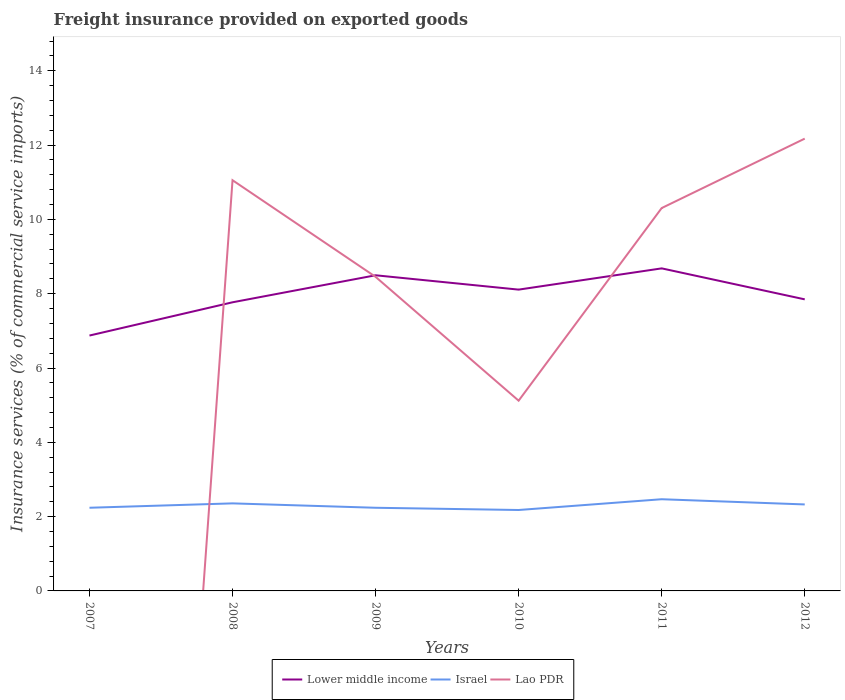Does the line corresponding to Lower middle income intersect with the line corresponding to Lao PDR?
Offer a very short reply. Yes. Is the number of lines equal to the number of legend labels?
Make the answer very short. No. Across all years, what is the maximum freight insurance provided on exported goods in Lower middle income?
Give a very brief answer. 6.87. What is the total freight insurance provided on exported goods in Lower middle income in the graph?
Ensure brevity in your answer.  -0.91. What is the difference between the highest and the second highest freight insurance provided on exported goods in Israel?
Offer a terse response. 0.29. What is the difference between the highest and the lowest freight insurance provided on exported goods in Lao PDR?
Offer a terse response. 4. Is the freight insurance provided on exported goods in Israel strictly greater than the freight insurance provided on exported goods in Lao PDR over the years?
Your response must be concise. No. How many lines are there?
Your response must be concise. 3. Does the graph contain grids?
Offer a terse response. No. What is the title of the graph?
Offer a very short reply. Freight insurance provided on exported goods. Does "Belarus" appear as one of the legend labels in the graph?
Ensure brevity in your answer.  No. What is the label or title of the X-axis?
Offer a terse response. Years. What is the label or title of the Y-axis?
Give a very brief answer. Insurance services (% of commercial service imports). What is the Insurance services (% of commercial service imports) of Lower middle income in 2007?
Ensure brevity in your answer.  6.87. What is the Insurance services (% of commercial service imports) in Israel in 2007?
Make the answer very short. 2.24. What is the Insurance services (% of commercial service imports) of Lao PDR in 2007?
Give a very brief answer. 0. What is the Insurance services (% of commercial service imports) of Lower middle income in 2008?
Give a very brief answer. 7.77. What is the Insurance services (% of commercial service imports) of Israel in 2008?
Make the answer very short. 2.36. What is the Insurance services (% of commercial service imports) of Lao PDR in 2008?
Offer a very short reply. 11.05. What is the Insurance services (% of commercial service imports) in Lower middle income in 2009?
Offer a terse response. 8.5. What is the Insurance services (% of commercial service imports) in Israel in 2009?
Make the answer very short. 2.24. What is the Insurance services (% of commercial service imports) of Lao PDR in 2009?
Your answer should be very brief. 8.45. What is the Insurance services (% of commercial service imports) of Lower middle income in 2010?
Give a very brief answer. 8.11. What is the Insurance services (% of commercial service imports) of Israel in 2010?
Your response must be concise. 2.18. What is the Insurance services (% of commercial service imports) of Lao PDR in 2010?
Provide a short and direct response. 5.12. What is the Insurance services (% of commercial service imports) of Lower middle income in 2011?
Your answer should be very brief. 8.68. What is the Insurance services (% of commercial service imports) in Israel in 2011?
Provide a succinct answer. 2.47. What is the Insurance services (% of commercial service imports) of Lao PDR in 2011?
Keep it short and to the point. 10.31. What is the Insurance services (% of commercial service imports) of Lower middle income in 2012?
Ensure brevity in your answer.  7.85. What is the Insurance services (% of commercial service imports) of Israel in 2012?
Your answer should be very brief. 2.33. What is the Insurance services (% of commercial service imports) in Lao PDR in 2012?
Offer a terse response. 12.17. Across all years, what is the maximum Insurance services (% of commercial service imports) of Lower middle income?
Make the answer very short. 8.68. Across all years, what is the maximum Insurance services (% of commercial service imports) of Israel?
Offer a very short reply. 2.47. Across all years, what is the maximum Insurance services (% of commercial service imports) of Lao PDR?
Provide a succinct answer. 12.17. Across all years, what is the minimum Insurance services (% of commercial service imports) of Lower middle income?
Your response must be concise. 6.87. Across all years, what is the minimum Insurance services (% of commercial service imports) of Israel?
Make the answer very short. 2.18. What is the total Insurance services (% of commercial service imports) in Lower middle income in the graph?
Make the answer very short. 47.78. What is the total Insurance services (% of commercial service imports) of Israel in the graph?
Your answer should be very brief. 13.81. What is the total Insurance services (% of commercial service imports) in Lao PDR in the graph?
Your answer should be very brief. 47.11. What is the difference between the Insurance services (% of commercial service imports) in Lower middle income in 2007 and that in 2008?
Your answer should be compact. -0.9. What is the difference between the Insurance services (% of commercial service imports) in Israel in 2007 and that in 2008?
Offer a very short reply. -0.12. What is the difference between the Insurance services (% of commercial service imports) of Lower middle income in 2007 and that in 2009?
Give a very brief answer. -1.62. What is the difference between the Insurance services (% of commercial service imports) of Lower middle income in 2007 and that in 2010?
Your answer should be very brief. -1.24. What is the difference between the Insurance services (% of commercial service imports) in Israel in 2007 and that in 2010?
Give a very brief answer. 0.06. What is the difference between the Insurance services (% of commercial service imports) in Lower middle income in 2007 and that in 2011?
Provide a succinct answer. -1.81. What is the difference between the Insurance services (% of commercial service imports) in Israel in 2007 and that in 2011?
Offer a very short reply. -0.23. What is the difference between the Insurance services (% of commercial service imports) in Lower middle income in 2007 and that in 2012?
Your answer should be very brief. -0.97. What is the difference between the Insurance services (% of commercial service imports) in Israel in 2007 and that in 2012?
Ensure brevity in your answer.  -0.09. What is the difference between the Insurance services (% of commercial service imports) in Lower middle income in 2008 and that in 2009?
Your answer should be very brief. -0.73. What is the difference between the Insurance services (% of commercial service imports) of Israel in 2008 and that in 2009?
Make the answer very short. 0.12. What is the difference between the Insurance services (% of commercial service imports) in Lao PDR in 2008 and that in 2009?
Make the answer very short. 2.6. What is the difference between the Insurance services (% of commercial service imports) of Lower middle income in 2008 and that in 2010?
Give a very brief answer. -0.34. What is the difference between the Insurance services (% of commercial service imports) in Israel in 2008 and that in 2010?
Your response must be concise. 0.18. What is the difference between the Insurance services (% of commercial service imports) of Lao PDR in 2008 and that in 2010?
Make the answer very short. 5.93. What is the difference between the Insurance services (% of commercial service imports) of Lower middle income in 2008 and that in 2011?
Your answer should be compact. -0.91. What is the difference between the Insurance services (% of commercial service imports) in Israel in 2008 and that in 2011?
Your response must be concise. -0.11. What is the difference between the Insurance services (% of commercial service imports) in Lao PDR in 2008 and that in 2011?
Your answer should be compact. 0.75. What is the difference between the Insurance services (% of commercial service imports) of Lower middle income in 2008 and that in 2012?
Make the answer very short. -0.08. What is the difference between the Insurance services (% of commercial service imports) of Israel in 2008 and that in 2012?
Your response must be concise. 0.03. What is the difference between the Insurance services (% of commercial service imports) of Lao PDR in 2008 and that in 2012?
Keep it short and to the point. -1.12. What is the difference between the Insurance services (% of commercial service imports) in Lower middle income in 2009 and that in 2010?
Your answer should be compact. 0.39. What is the difference between the Insurance services (% of commercial service imports) of Israel in 2009 and that in 2010?
Keep it short and to the point. 0.06. What is the difference between the Insurance services (% of commercial service imports) in Lao PDR in 2009 and that in 2010?
Give a very brief answer. 3.33. What is the difference between the Insurance services (% of commercial service imports) in Lower middle income in 2009 and that in 2011?
Offer a very short reply. -0.19. What is the difference between the Insurance services (% of commercial service imports) in Israel in 2009 and that in 2011?
Provide a succinct answer. -0.23. What is the difference between the Insurance services (% of commercial service imports) of Lao PDR in 2009 and that in 2011?
Offer a very short reply. -1.85. What is the difference between the Insurance services (% of commercial service imports) of Lower middle income in 2009 and that in 2012?
Your answer should be compact. 0.65. What is the difference between the Insurance services (% of commercial service imports) of Israel in 2009 and that in 2012?
Provide a succinct answer. -0.09. What is the difference between the Insurance services (% of commercial service imports) in Lao PDR in 2009 and that in 2012?
Provide a short and direct response. -3.72. What is the difference between the Insurance services (% of commercial service imports) of Lower middle income in 2010 and that in 2011?
Offer a terse response. -0.57. What is the difference between the Insurance services (% of commercial service imports) in Israel in 2010 and that in 2011?
Offer a very short reply. -0.29. What is the difference between the Insurance services (% of commercial service imports) of Lao PDR in 2010 and that in 2011?
Keep it short and to the point. -5.18. What is the difference between the Insurance services (% of commercial service imports) of Lower middle income in 2010 and that in 2012?
Your answer should be compact. 0.26. What is the difference between the Insurance services (% of commercial service imports) of Israel in 2010 and that in 2012?
Provide a succinct answer. -0.15. What is the difference between the Insurance services (% of commercial service imports) in Lao PDR in 2010 and that in 2012?
Your answer should be compact. -7.05. What is the difference between the Insurance services (% of commercial service imports) of Lower middle income in 2011 and that in 2012?
Ensure brevity in your answer.  0.83. What is the difference between the Insurance services (% of commercial service imports) of Israel in 2011 and that in 2012?
Offer a very short reply. 0.14. What is the difference between the Insurance services (% of commercial service imports) in Lao PDR in 2011 and that in 2012?
Your response must be concise. -1.87. What is the difference between the Insurance services (% of commercial service imports) of Lower middle income in 2007 and the Insurance services (% of commercial service imports) of Israel in 2008?
Provide a succinct answer. 4.52. What is the difference between the Insurance services (% of commercial service imports) of Lower middle income in 2007 and the Insurance services (% of commercial service imports) of Lao PDR in 2008?
Provide a short and direct response. -4.18. What is the difference between the Insurance services (% of commercial service imports) in Israel in 2007 and the Insurance services (% of commercial service imports) in Lao PDR in 2008?
Give a very brief answer. -8.82. What is the difference between the Insurance services (% of commercial service imports) of Lower middle income in 2007 and the Insurance services (% of commercial service imports) of Israel in 2009?
Your response must be concise. 4.64. What is the difference between the Insurance services (% of commercial service imports) in Lower middle income in 2007 and the Insurance services (% of commercial service imports) in Lao PDR in 2009?
Your answer should be compact. -1.58. What is the difference between the Insurance services (% of commercial service imports) of Israel in 2007 and the Insurance services (% of commercial service imports) of Lao PDR in 2009?
Give a very brief answer. -6.22. What is the difference between the Insurance services (% of commercial service imports) of Lower middle income in 2007 and the Insurance services (% of commercial service imports) of Israel in 2010?
Your answer should be compact. 4.7. What is the difference between the Insurance services (% of commercial service imports) of Lower middle income in 2007 and the Insurance services (% of commercial service imports) of Lao PDR in 2010?
Ensure brevity in your answer.  1.75. What is the difference between the Insurance services (% of commercial service imports) of Israel in 2007 and the Insurance services (% of commercial service imports) of Lao PDR in 2010?
Offer a terse response. -2.88. What is the difference between the Insurance services (% of commercial service imports) of Lower middle income in 2007 and the Insurance services (% of commercial service imports) of Israel in 2011?
Make the answer very short. 4.41. What is the difference between the Insurance services (% of commercial service imports) of Lower middle income in 2007 and the Insurance services (% of commercial service imports) of Lao PDR in 2011?
Your answer should be compact. -3.43. What is the difference between the Insurance services (% of commercial service imports) of Israel in 2007 and the Insurance services (% of commercial service imports) of Lao PDR in 2011?
Provide a succinct answer. -8.07. What is the difference between the Insurance services (% of commercial service imports) in Lower middle income in 2007 and the Insurance services (% of commercial service imports) in Israel in 2012?
Make the answer very short. 4.55. What is the difference between the Insurance services (% of commercial service imports) in Lower middle income in 2007 and the Insurance services (% of commercial service imports) in Lao PDR in 2012?
Your response must be concise. -5.3. What is the difference between the Insurance services (% of commercial service imports) in Israel in 2007 and the Insurance services (% of commercial service imports) in Lao PDR in 2012?
Your answer should be very brief. -9.94. What is the difference between the Insurance services (% of commercial service imports) in Lower middle income in 2008 and the Insurance services (% of commercial service imports) in Israel in 2009?
Provide a short and direct response. 5.53. What is the difference between the Insurance services (% of commercial service imports) in Lower middle income in 2008 and the Insurance services (% of commercial service imports) in Lao PDR in 2009?
Your answer should be compact. -0.68. What is the difference between the Insurance services (% of commercial service imports) of Israel in 2008 and the Insurance services (% of commercial service imports) of Lao PDR in 2009?
Make the answer very short. -6.1. What is the difference between the Insurance services (% of commercial service imports) of Lower middle income in 2008 and the Insurance services (% of commercial service imports) of Israel in 2010?
Keep it short and to the point. 5.59. What is the difference between the Insurance services (% of commercial service imports) in Lower middle income in 2008 and the Insurance services (% of commercial service imports) in Lao PDR in 2010?
Offer a very short reply. 2.65. What is the difference between the Insurance services (% of commercial service imports) of Israel in 2008 and the Insurance services (% of commercial service imports) of Lao PDR in 2010?
Offer a terse response. -2.76. What is the difference between the Insurance services (% of commercial service imports) in Lower middle income in 2008 and the Insurance services (% of commercial service imports) in Israel in 2011?
Give a very brief answer. 5.3. What is the difference between the Insurance services (% of commercial service imports) of Lower middle income in 2008 and the Insurance services (% of commercial service imports) of Lao PDR in 2011?
Offer a very short reply. -2.54. What is the difference between the Insurance services (% of commercial service imports) in Israel in 2008 and the Insurance services (% of commercial service imports) in Lao PDR in 2011?
Make the answer very short. -7.95. What is the difference between the Insurance services (% of commercial service imports) of Lower middle income in 2008 and the Insurance services (% of commercial service imports) of Israel in 2012?
Your response must be concise. 5.44. What is the difference between the Insurance services (% of commercial service imports) in Lower middle income in 2008 and the Insurance services (% of commercial service imports) in Lao PDR in 2012?
Provide a short and direct response. -4.41. What is the difference between the Insurance services (% of commercial service imports) in Israel in 2008 and the Insurance services (% of commercial service imports) in Lao PDR in 2012?
Your response must be concise. -9.82. What is the difference between the Insurance services (% of commercial service imports) of Lower middle income in 2009 and the Insurance services (% of commercial service imports) of Israel in 2010?
Ensure brevity in your answer.  6.32. What is the difference between the Insurance services (% of commercial service imports) of Lower middle income in 2009 and the Insurance services (% of commercial service imports) of Lao PDR in 2010?
Give a very brief answer. 3.38. What is the difference between the Insurance services (% of commercial service imports) of Israel in 2009 and the Insurance services (% of commercial service imports) of Lao PDR in 2010?
Offer a very short reply. -2.88. What is the difference between the Insurance services (% of commercial service imports) of Lower middle income in 2009 and the Insurance services (% of commercial service imports) of Israel in 2011?
Offer a terse response. 6.03. What is the difference between the Insurance services (% of commercial service imports) in Lower middle income in 2009 and the Insurance services (% of commercial service imports) in Lao PDR in 2011?
Your answer should be compact. -1.81. What is the difference between the Insurance services (% of commercial service imports) in Israel in 2009 and the Insurance services (% of commercial service imports) in Lao PDR in 2011?
Make the answer very short. -8.07. What is the difference between the Insurance services (% of commercial service imports) in Lower middle income in 2009 and the Insurance services (% of commercial service imports) in Israel in 2012?
Your answer should be compact. 6.17. What is the difference between the Insurance services (% of commercial service imports) of Lower middle income in 2009 and the Insurance services (% of commercial service imports) of Lao PDR in 2012?
Your answer should be very brief. -3.68. What is the difference between the Insurance services (% of commercial service imports) in Israel in 2009 and the Insurance services (% of commercial service imports) in Lao PDR in 2012?
Your answer should be compact. -9.94. What is the difference between the Insurance services (% of commercial service imports) in Lower middle income in 2010 and the Insurance services (% of commercial service imports) in Israel in 2011?
Provide a succinct answer. 5.64. What is the difference between the Insurance services (% of commercial service imports) of Lower middle income in 2010 and the Insurance services (% of commercial service imports) of Lao PDR in 2011?
Your response must be concise. -2.2. What is the difference between the Insurance services (% of commercial service imports) in Israel in 2010 and the Insurance services (% of commercial service imports) in Lao PDR in 2011?
Provide a succinct answer. -8.13. What is the difference between the Insurance services (% of commercial service imports) of Lower middle income in 2010 and the Insurance services (% of commercial service imports) of Israel in 2012?
Make the answer very short. 5.78. What is the difference between the Insurance services (% of commercial service imports) in Lower middle income in 2010 and the Insurance services (% of commercial service imports) in Lao PDR in 2012?
Your answer should be compact. -4.06. What is the difference between the Insurance services (% of commercial service imports) of Israel in 2010 and the Insurance services (% of commercial service imports) of Lao PDR in 2012?
Provide a short and direct response. -10. What is the difference between the Insurance services (% of commercial service imports) of Lower middle income in 2011 and the Insurance services (% of commercial service imports) of Israel in 2012?
Offer a very short reply. 6.35. What is the difference between the Insurance services (% of commercial service imports) in Lower middle income in 2011 and the Insurance services (% of commercial service imports) in Lao PDR in 2012?
Give a very brief answer. -3.49. What is the difference between the Insurance services (% of commercial service imports) in Israel in 2011 and the Insurance services (% of commercial service imports) in Lao PDR in 2012?
Give a very brief answer. -9.71. What is the average Insurance services (% of commercial service imports) of Lower middle income per year?
Your answer should be very brief. 7.96. What is the average Insurance services (% of commercial service imports) of Israel per year?
Offer a very short reply. 2.3. What is the average Insurance services (% of commercial service imports) in Lao PDR per year?
Make the answer very short. 7.85. In the year 2007, what is the difference between the Insurance services (% of commercial service imports) of Lower middle income and Insurance services (% of commercial service imports) of Israel?
Offer a very short reply. 4.64. In the year 2008, what is the difference between the Insurance services (% of commercial service imports) in Lower middle income and Insurance services (% of commercial service imports) in Israel?
Your answer should be very brief. 5.41. In the year 2008, what is the difference between the Insurance services (% of commercial service imports) of Lower middle income and Insurance services (% of commercial service imports) of Lao PDR?
Keep it short and to the point. -3.29. In the year 2008, what is the difference between the Insurance services (% of commercial service imports) in Israel and Insurance services (% of commercial service imports) in Lao PDR?
Ensure brevity in your answer.  -8.7. In the year 2009, what is the difference between the Insurance services (% of commercial service imports) in Lower middle income and Insurance services (% of commercial service imports) in Israel?
Ensure brevity in your answer.  6.26. In the year 2009, what is the difference between the Insurance services (% of commercial service imports) of Lower middle income and Insurance services (% of commercial service imports) of Lao PDR?
Your answer should be very brief. 0.04. In the year 2009, what is the difference between the Insurance services (% of commercial service imports) of Israel and Insurance services (% of commercial service imports) of Lao PDR?
Provide a short and direct response. -6.22. In the year 2010, what is the difference between the Insurance services (% of commercial service imports) in Lower middle income and Insurance services (% of commercial service imports) in Israel?
Offer a very short reply. 5.93. In the year 2010, what is the difference between the Insurance services (% of commercial service imports) of Lower middle income and Insurance services (% of commercial service imports) of Lao PDR?
Provide a succinct answer. 2.99. In the year 2010, what is the difference between the Insurance services (% of commercial service imports) of Israel and Insurance services (% of commercial service imports) of Lao PDR?
Your answer should be very brief. -2.94. In the year 2011, what is the difference between the Insurance services (% of commercial service imports) in Lower middle income and Insurance services (% of commercial service imports) in Israel?
Offer a very short reply. 6.21. In the year 2011, what is the difference between the Insurance services (% of commercial service imports) of Lower middle income and Insurance services (% of commercial service imports) of Lao PDR?
Your answer should be compact. -1.62. In the year 2011, what is the difference between the Insurance services (% of commercial service imports) in Israel and Insurance services (% of commercial service imports) in Lao PDR?
Give a very brief answer. -7.84. In the year 2012, what is the difference between the Insurance services (% of commercial service imports) of Lower middle income and Insurance services (% of commercial service imports) of Israel?
Give a very brief answer. 5.52. In the year 2012, what is the difference between the Insurance services (% of commercial service imports) of Lower middle income and Insurance services (% of commercial service imports) of Lao PDR?
Provide a succinct answer. -4.33. In the year 2012, what is the difference between the Insurance services (% of commercial service imports) in Israel and Insurance services (% of commercial service imports) in Lao PDR?
Keep it short and to the point. -9.85. What is the ratio of the Insurance services (% of commercial service imports) of Lower middle income in 2007 to that in 2008?
Provide a succinct answer. 0.88. What is the ratio of the Insurance services (% of commercial service imports) in Israel in 2007 to that in 2008?
Provide a succinct answer. 0.95. What is the ratio of the Insurance services (% of commercial service imports) in Lower middle income in 2007 to that in 2009?
Provide a succinct answer. 0.81. What is the ratio of the Insurance services (% of commercial service imports) in Lower middle income in 2007 to that in 2010?
Provide a succinct answer. 0.85. What is the ratio of the Insurance services (% of commercial service imports) of Israel in 2007 to that in 2010?
Your answer should be very brief. 1.03. What is the ratio of the Insurance services (% of commercial service imports) in Lower middle income in 2007 to that in 2011?
Your response must be concise. 0.79. What is the ratio of the Insurance services (% of commercial service imports) in Israel in 2007 to that in 2011?
Provide a short and direct response. 0.91. What is the ratio of the Insurance services (% of commercial service imports) in Lower middle income in 2007 to that in 2012?
Provide a short and direct response. 0.88. What is the ratio of the Insurance services (% of commercial service imports) of Israel in 2007 to that in 2012?
Your answer should be compact. 0.96. What is the ratio of the Insurance services (% of commercial service imports) in Lower middle income in 2008 to that in 2009?
Provide a succinct answer. 0.91. What is the ratio of the Insurance services (% of commercial service imports) in Israel in 2008 to that in 2009?
Your response must be concise. 1.05. What is the ratio of the Insurance services (% of commercial service imports) in Lao PDR in 2008 to that in 2009?
Your answer should be very brief. 1.31. What is the ratio of the Insurance services (% of commercial service imports) in Lower middle income in 2008 to that in 2010?
Ensure brevity in your answer.  0.96. What is the ratio of the Insurance services (% of commercial service imports) in Israel in 2008 to that in 2010?
Make the answer very short. 1.08. What is the ratio of the Insurance services (% of commercial service imports) in Lao PDR in 2008 to that in 2010?
Your answer should be compact. 2.16. What is the ratio of the Insurance services (% of commercial service imports) in Lower middle income in 2008 to that in 2011?
Provide a short and direct response. 0.89. What is the ratio of the Insurance services (% of commercial service imports) in Israel in 2008 to that in 2011?
Provide a succinct answer. 0.95. What is the ratio of the Insurance services (% of commercial service imports) of Lao PDR in 2008 to that in 2011?
Provide a succinct answer. 1.07. What is the ratio of the Insurance services (% of commercial service imports) of Israel in 2008 to that in 2012?
Offer a terse response. 1.01. What is the ratio of the Insurance services (% of commercial service imports) of Lao PDR in 2008 to that in 2012?
Offer a terse response. 0.91. What is the ratio of the Insurance services (% of commercial service imports) in Lower middle income in 2009 to that in 2010?
Ensure brevity in your answer.  1.05. What is the ratio of the Insurance services (% of commercial service imports) of Israel in 2009 to that in 2010?
Offer a very short reply. 1.03. What is the ratio of the Insurance services (% of commercial service imports) in Lao PDR in 2009 to that in 2010?
Provide a short and direct response. 1.65. What is the ratio of the Insurance services (% of commercial service imports) in Lower middle income in 2009 to that in 2011?
Keep it short and to the point. 0.98. What is the ratio of the Insurance services (% of commercial service imports) in Israel in 2009 to that in 2011?
Your answer should be compact. 0.91. What is the ratio of the Insurance services (% of commercial service imports) of Lao PDR in 2009 to that in 2011?
Your answer should be very brief. 0.82. What is the ratio of the Insurance services (% of commercial service imports) of Lower middle income in 2009 to that in 2012?
Ensure brevity in your answer.  1.08. What is the ratio of the Insurance services (% of commercial service imports) of Israel in 2009 to that in 2012?
Offer a terse response. 0.96. What is the ratio of the Insurance services (% of commercial service imports) of Lao PDR in 2009 to that in 2012?
Offer a very short reply. 0.69. What is the ratio of the Insurance services (% of commercial service imports) of Lower middle income in 2010 to that in 2011?
Give a very brief answer. 0.93. What is the ratio of the Insurance services (% of commercial service imports) in Israel in 2010 to that in 2011?
Offer a terse response. 0.88. What is the ratio of the Insurance services (% of commercial service imports) of Lao PDR in 2010 to that in 2011?
Ensure brevity in your answer.  0.5. What is the ratio of the Insurance services (% of commercial service imports) of Lower middle income in 2010 to that in 2012?
Make the answer very short. 1.03. What is the ratio of the Insurance services (% of commercial service imports) of Israel in 2010 to that in 2012?
Offer a very short reply. 0.94. What is the ratio of the Insurance services (% of commercial service imports) of Lao PDR in 2010 to that in 2012?
Keep it short and to the point. 0.42. What is the ratio of the Insurance services (% of commercial service imports) in Lower middle income in 2011 to that in 2012?
Give a very brief answer. 1.11. What is the ratio of the Insurance services (% of commercial service imports) in Israel in 2011 to that in 2012?
Give a very brief answer. 1.06. What is the ratio of the Insurance services (% of commercial service imports) in Lao PDR in 2011 to that in 2012?
Your response must be concise. 0.85. What is the difference between the highest and the second highest Insurance services (% of commercial service imports) in Lower middle income?
Keep it short and to the point. 0.19. What is the difference between the highest and the second highest Insurance services (% of commercial service imports) in Israel?
Your answer should be compact. 0.11. What is the difference between the highest and the second highest Insurance services (% of commercial service imports) of Lao PDR?
Provide a succinct answer. 1.12. What is the difference between the highest and the lowest Insurance services (% of commercial service imports) of Lower middle income?
Your answer should be very brief. 1.81. What is the difference between the highest and the lowest Insurance services (% of commercial service imports) in Israel?
Your response must be concise. 0.29. What is the difference between the highest and the lowest Insurance services (% of commercial service imports) of Lao PDR?
Provide a short and direct response. 12.17. 